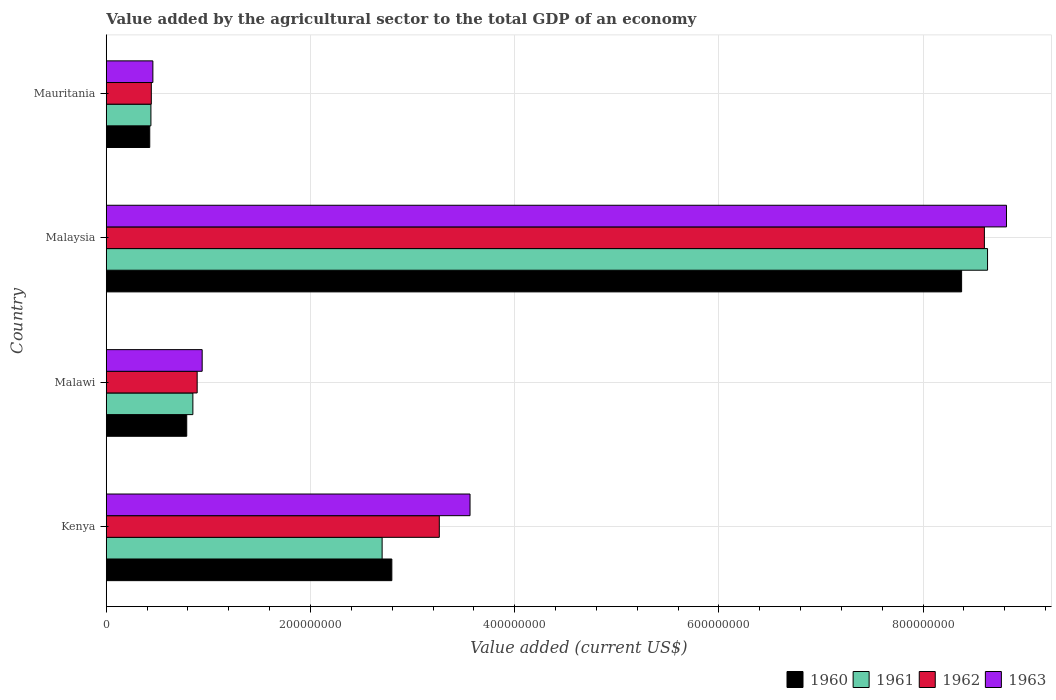Are the number of bars per tick equal to the number of legend labels?
Give a very brief answer. Yes. Are the number of bars on each tick of the Y-axis equal?
Keep it short and to the point. Yes. What is the label of the 4th group of bars from the top?
Your response must be concise. Kenya. In how many cases, is the number of bars for a given country not equal to the number of legend labels?
Provide a short and direct response. 0. What is the value added by the agricultural sector to the total GDP in 1961 in Malaysia?
Your response must be concise. 8.63e+08. Across all countries, what is the maximum value added by the agricultural sector to the total GDP in 1961?
Offer a very short reply. 8.63e+08. Across all countries, what is the minimum value added by the agricultural sector to the total GDP in 1963?
Offer a very short reply. 4.57e+07. In which country was the value added by the agricultural sector to the total GDP in 1962 maximum?
Provide a short and direct response. Malaysia. In which country was the value added by the agricultural sector to the total GDP in 1963 minimum?
Offer a terse response. Mauritania. What is the total value added by the agricultural sector to the total GDP in 1961 in the graph?
Provide a short and direct response. 1.26e+09. What is the difference between the value added by the agricultural sector to the total GDP in 1961 in Malaysia and that in Mauritania?
Keep it short and to the point. 8.19e+08. What is the difference between the value added by the agricultural sector to the total GDP in 1963 in Kenya and the value added by the agricultural sector to the total GDP in 1961 in Mauritania?
Make the answer very short. 3.13e+08. What is the average value added by the agricultural sector to the total GDP in 1963 per country?
Provide a succinct answer. 3.44e+08. What is the difference between the value added by the agricultural sector to the total GDP in 1960 and value added by the agricultural sector to the total GDP in 1962 in Kenya?
Give a very brief answer. -4.65e+07. What is the ratio of the value added by the agricultural sector to the total GDP in 1963 in Kenya to that in Mauritania?
Keep it short and to the point. 7.8. What is the difference between the highest and the second highest value added by the agricultural sector to the total GDP in 1961?
Offer a terse response. 5.93e+08. What is the difference between the highest and the lowest value added by the agricultural sector to the total GDP in 1961?
Your answer should be very brief. 8.19e+08. Is the sum of the value added by the agricultural sector to the total GDP in 1961 in Malaysia and Mauritania greater than the maximum value added by the agricultural sector to the total GDP in 1960 across all countries?
Offer a very short reply. Yes. Is it the case that in every country, the sum of the value added by the agricultural sector to the total GDP in 1962 and value added by the agricultural sector to the total GDP in 1961 is greater than the sum of value added by the agricultural sector to the total GDP in 1963 and value added by the agricultural sector to the total GDP in 1960?
Make the answer very short. No. What does the 4th bar from the top in Mauritania represents?
Offer a very short reply. 1960. What does the 3rd bar from the bottom in Mauritania represents?
Give a very brief answer. 1962. How many bars are there?
Make the answer very short. 16. Are the values on the major ticks of X-axis written in scientific E-notation?
Offer a terse response. No. Does the graph contain any zero values?
Make the answer very short. No. Does the graph contain grids?
Offer a very short reply. Yes. Where does the legend appear in the graph?
Your response must be concise. Bottom right. How are the legend labels stacked?
Your answer should be compact. Horizontal. What is the title of the graph?
Your answer should be compact. Value added by the agricultural sector to the total GDP of an economy. Does "2010" appear as one of the legend labels in the graph?
Offer a very short reply. No. What is the label or title of the X-axis?
Your response must be concise. Value added (current US$). What is the label or title of the Y-axis?
Provide a short and direct response. Country. What is the Value added (current US$) in 1960 in Kenya?
Your answer should be compact. 2.80e+08. What is the Value added (current US$) of 1961 in Kenya?
Provide a succinct answer. 2.70e+08. What is the Value added (current US$) in 1962 in Kenya?
Provide a short and direct response. 3.26e+08. What is the Value added (current US$) of 1963 in Kenya?
Your response must be concise. 3.56e+08. What is the Value added (current US$) in 1960 in Malawi?
Your answer should be compact. 7.88e+07. What is the Value added (current US$) of 1961 in Malawi?
Ensure brevity in your answer.  8.48e+07. What is the Value added (current US$) in 1962 in Malawi?
Your response must be concise. 8.90e+07. What is the Value added (current US$) of 1963 in Malawi?
Give a very brief answer. 9.39e+07. What is the Value added (current US$) in 1960 in Malaysia?
Offer a terse response. 8.38e+08. What is the Value added (current US$) in 1961 in Malaysia?
Provide a succinct answer. 8.63e+08. What is the Value added (current US$) of 1962 in Malaysia?
Your answer should be very brief. 8.60e+08. What is the Value added (current US$) in 1963 in Malaysia?
Your answer should be compact. 8.82e+08. What is the Value added (current US$) of 1960 in Mauritania?
Offer a very short reply. 4.26e+07. What is the Value added (current US$) of 1961 in Mauritania?
Your answer should be very brief. 4.37e+07. What is the Value added (current US$) of 1962 in Mauritania?
Offer a very short reply. 4.41e+07. What is the Value added (current US$) of 1963 in Mauritania?
Give a very brief answer. 4.57e+07. Across all countries, what is the maximum Value added (current US$) in 1960?
Offer a terse response. 8.38e+08. Across all countries, what is the maximum Value added (current US$) in 1961?
Your response must be concise. 8.63e+08. Across all countries, what is the maximum Value added (current US$) of 1962?
Your response must be concise. 8.60e+08. Across all countries, what is the maximum Value added (current US$) of 1963?
Your answer should be compact. 8.82e+08. Across all countries, what is the minimum Value added (current US$) of 1960?
Provide a succinct answer. 4.26e+07. Across all countries, what is the minimum Value added (current US$) of 1961?
Offer a very short reply. 4.37e+07. Across all countries, what is the minimum Value added (current US$) in 1962?
Keep it short and to the point. 4.41e+07. Across all countries, what is the minimum Value added (current US$) in 1963?
Your response must be concise. 4.57e+07. What is the total Value added (current US$) in 1960 in the graph?
Your response must be concise. 1.24e+09. What is the total Value added (current US$) of 1961 in the graph?
Give a very brief answer. 1.26e+09. What is the total Value added (current US$) of 1962 in the graph?
Your answer should be very brief. 1.32e+09. What is the total Value added (current US$) of 1963 in the graph?
Keep it short and to the point. 1.38e+09. What is the difference between the Value added (current US$) in 1960 in Kenya and that in Malawi?
Give a very brief answer. 2.01e+08. What is the difference between the Value added (current US$) in 1961 in Kenya and that in Malawi?
Provide a short and direct response. 1.85e+08. What is the difference between the Value added (current US$) of 1962 in Kenya and that in Malawi?
Offer a very short reply. 2.37e+08. What is the difference between the Value added (current US$) of 1963 in Kenya and that in Malawi?
Provide a succinct answer. 2.62e+08. What is the difference between the Value added (current US$) of 1960 in Kenya and that in Malaysia?
Your answer should be very brief. -5.58e+08. What is the difference between the Value added (current US$) of 1961 in Kenya and that in Malaysia?
Ensure brevity in your answer.  -5.93e+08. What is the difference between the Value added (current US$) in 1962 in Kenya and that in Malaysia?
Make the answer very short. -5.34e+08. What is the difference between the Value added (current US$) of 1963 in Kenya and that in Malaysia?
Offer a terse response. -5.25e+08. What is the difference between the Value added (current US$) in 1960 in Kenya and that in Mauritania?
Make the answer very short. 2.37e+08. What is the difference between the Value added (current US$) in 1961 in Kenya and that in Mauritania?
Provide a short and direct response. 2.26e+08. What is the difference between the Value added (current US$) of 1962 in Kenya and that in Mauritania?
Make the answer very short. 2.82e+08. What is the difference between the Value added (current US$) of 1963 in Kenya and that in Mauritania?
Ensure brevity in your answer.  3.11e+08. What is the difference between the Value added (current US$) of 1960 in Malawi and that in Malaysia?
Give a very brief answer. -7.59e+08. What is the difference between the Value added (current US$) of 1961 in Malawi and that in Malaysia?
Your response must be concise. -7.78e+08. What is the difference between the Value added (current US$) in 1962 in Malawi and that in Malaysia?
Keep it short and to the point. -7.71e+08. What is the difference between the Value added (current US$) of 1963 in Malawi and that in Malaysia?
Offer a very short reply. -7.88e+08. What is the difference between the Value added (current US$) in 1960 in Malawi and that in Mauritania?
Provide a short and direct response. 3.62e+07. What is the difference between the Value added (current US$) in 1961 in Malawi and that in Mauritania?
Provide a succinct answer. 4.11e+07. What is the difference between the Value added (current US$) of 1962 in Malawi and that in Mauritania?
Provide a short and direct response. 4.49e+07. What is the difference between the Value added (current US$) of 1963 in Malawi and that in Mauritania?
Provide a short and direct response. 4.83e+07. What is the difference between the Value added (current US$) of 1960 in Malaysia and that in Mauritania?
Keep it short and to the point. 7.95e+08. What is the difference between the Value added (current US$) of 1961 in Malaysia and that in Mauritania?
Your answer should be compact. 8.19e+08. What is the difference between the Value added (current US$) in 1962 in Malaysia and that in Mauritania?
Provide a succinct answer. 8.16e+08. What is the difference between the Value added (current US$) in 1963 in Malaysia and that in Mauritania?
Keep it short and to the point. 8.36e+08. What is the difference between the Value added (current US$) of 1960 in Kenya and the Value added (current US$) of 1961 in Malawi?
Your answer should be very brief. 1.95e+08. What is the difference between the Value added (current US$) of 1960 in Kenya and the Value added (current US$) of 1962 in Malawi?
Provide a succinct answer. 1.91e+08. What is the difference between the Value added (current US$) of 1960 in Kenya and the Value added (current US$) of 1963 in Malawi?
Ensure brevity in your answer.  1.86e+08. What is the difference between the Value added (current US$) of 1961 in Kenya and the Value added (current US$) of 1962 in Malawi?
Give a very brief answer. 1.81e+08. What is the difference between the Value added (current US$) in 1961 in Kenya and the Value added (current US$) in 1963 in Malawi?
Provide a succinct answer. 1.76e+08. What is the difference between the Value added (current US$) in 1962 in Kenya and the Value added (current US$) in 1963 in Malawi?
Provide a short and direct response. 2.32e+08. What is the difference between the Value added (current US$) of 1960 in Kenya and the Value added (current US$) of 1961 in Malaysia?
Your response must be concise. -5.83e+08. What is the difference between the Value added (current US$) of 1960 in Kenya and the Value added (current US$) of 1962 in Malaysia?
Make the answer very short. -5.80e+08. What is the difference between the Value added (current US$) in 1960 in Kenya and the Value added (current US$) in 1963 in Malaysia?
Your answer should be very brief. -6.02e+08. What is the difference between the Value added (current US$) of 1961 in Kenya and the Value added (current US$) of 1962 in Malaysia?
Give a very brief answer. -5.90e+08. What is the difference between the Value added (current US$) of 1961 in Kenya and the Value added (current US$) of 1963 in Malaysia?
Your response must be concise. -6.11e+08. What is the difference between the Value added (current US$) of 1962 in Kenya and the Value added (current US$) of 1963 in Malaysia?
Offer a terse response. -5.55e+08. What is the difference between the Value added (current US$) of 1960 in Kenya and the Value added (current US$) of 1961 in Mauritania?
Offer a terse response. 2.36e+08. What is the difference between the Value added (current US$) of 1960 in Kenya and the Value added (current US$) of 1962 in Mauritania?
Your answer should be very brief. 2.36e+08. What is the difference between the Value added (current US$) in 1960 in Kenya and the Value added (current US$) in 1963 in Mauritania?
Keep it short and to the point. 2.34e+08. What is the difference between the Value added (current US$) of 1961 in Kenya and the Value added (current US$) of 1962 in Mauritania?
Give a very brief answer. 2.26e+08. What is the difference between the Value added (current US$) in 1961 in Kenya and the Value added (current US$) in 1963 in Mauritania?
Ensure brevity in your answer.  2.25e+08. What is the difference between the Value added (current US$) in 1962 in Kenya and the Value added (current US$) in 1963 in Mauritania?
Your answer should be compact. 2.81e+08. What is the difference between the Value added (current US$) in 1960 in Malawi and the Value added (current US$) in 1961 in Malaysia?
Your answer should be compact. -7.84e+08. What is the difference between the Value added (current US$) of 1960 in Malawi and the Value added (current US$) of 1962 in Malaysia?
Make the answer very short. -7.81e+08. What is the difference between the Value added (current US$) of 1960 in Malawi and the Value added (current US$) of 1963 in Malaysia?
Your response must be concise. -8.03e+08. What is the difference between the Value added (current US$) of 1961 in Malawi and the Value added (current US$) of 1962 in Malaysia?
Provide a short and direct response. -7.75e+08. What is the difference between the Value added (current US$) of 1961 in Malawi and the Value added (current US$) of 1963 in Malaysia?
Offer a very short reply. -7.97e+08. What is the difference between the Value added (current US$) in 1962 in Malawi and the Value added (current US$) in 1963 in Malaysia?
Give a very brief answer. -7.93e+08. What is the difference between the Value added (current US$) of 1960 in Malawi and the Value added (current US$) of 1961 in Mauritania?
Provide a succinct answer. 3.51e+07. What is the difference between the Value added (current US$) in 1960 in Malawi and the Value added (current US$) in 1962 in Mauritania?
Your answer should be compact. 3.47e+07. What is the difference between the Value added (current US$) of 1960 in Malawi and the Value added (current US$) of 1963 in Mauritania?
Provide a short and direct response. 3.32e+07. What is the difference between the Value added (current US$) of 1961 in Malawi and the Value added (current US$) of 1962 in Mauritania?
Ensure brevity in your answer.  4.07e+07. What is the difference between the Value added (current US$) in 1961 in Malawi and the Value added (current US$) in 1963 in Mauritania?
Ensure brevity in your answer.  3.92e+07. What is the difference between the Value added (current US$) of 1962 in Malawi and the Value added (current US$) of 1963 in Mauritania?
Provide a succinct answer. 4.34e+07. What is the difference between the Value added (current US$) in 1960 in Malaysia and the Value added (current US$) in 1961 in Mauritania?
Your answer should be compact. 7.94e+08. What is the difference between the Value added (current US$) of 1960 in Malaysia and the Value added (current US$) of 1962 in Mauritania?
Offer a terse response. 7.94e+08. What is the difference between the Value added (current US$) in 1960 in Malaysia and the Value added (current US$) in 1963 in Mauritania?
Offer a very short reply. 7.92e+08. What is the difference between the Value added (current US$) of 1961 in Malaysia and the Value added (current US$) of 1962 in Mauritania?
Keep it short and to the point. 8.19e+08. What is the difference between the Value added (current US$) of 1961 in Malaysia and the Value added (current US$) of 1963 in Mauritania?
Keep it short and to the point. 8.17e+08. What is the difference between the Value added (current US$) in 1962 in Malaysia and the Value added (current US$) in 1963 in Mauritania?
Your response must be concise. 8.14e+08. What is the average Value added (current US$) of 1960 per country?
Make the answer very short. 3.10e+08. What is the average Value added (current US$) of 1961 per country?
Your response must be concise. 3.15e+08. What is the average Value added (current US$) of 1962 per country?
Offer a terse response. 3.30e+08. What is the average Value added (current US$) of 1963 per country?
Offer a very short reply. 3.44e+08. What is the difference between the Value added (current US$) of 1960 and Value added (current US$) of 1961 in Kenya?
Ensure brevity in your answer.  9.51e+06. What is the difference between the Value added (current US$) in 1960 and Value added (current US$) in 1962 in Kenya?
Your response must be concise. -4.65e+07. What is the difference between the Value added (current US$) of 1960 and Value added (current US$) of 1963 in Kenya?
Offer a terse response. -7.66e+07. What is the difference between the Value added (current US$) of 1961 and Value added (current US$) of 1962 in Kenya?
Offer a very short reply. -5.60e+07. What is the difference between the Value added (current US$) of 1961 and Value added (current US$) of 1963 in Kenya?
Your answer should be very brief. -8.61e+07. What is the difference between the Value added (current US$) in 1962 and Value added (current US$) in 1963 in Kenya?
Provide a succinct answer. -3.01e+07. What is the difference between the Value added (current US$) of 1960 and Value added (current US$) of 1961 in Malawi?
Your answer should be very brief. -6.02e+06. What is the difference between the Value added (current US$) in 1960 and Value added (current US$) in 1962 in Malawi?
Give a very brief answer. -1.02e+07. What is the difference between the Value added (current US$) of 1960 and Value added (current US$) of 1963 in Malawi?
Provide a short and direct response. -1.51e+07. What is the difference between the Value added (current US$) of 1961 and Value added (current US$) of 1962 in Malawi?
Your answer should be very brief. -4.20e+06. What is the difference between the Value added (current US$) of 1961 and Value added (current US$) of 1963 in Malawi?
Provide a succinct answer. -9.10e+06. What is the difference between the Value added (current US$) of 1962 and Value added (current US$) of 1963 in Malawi?
Your answer should be compact. -4.90e+06. What is the difference between the Value added (current US$) of 1960 and Value added (current US$) of 1961 in Malaysia?
Give a very brief answer. -2.54e+07. What is the difference between the Value added (current US$) in 1960 and Value added (current US$) in 1962 in Malaysia?
Your answer should be very brief. -2.23e+07. What is the difference between the Value added (current US$) in 1960 and Value added (current US$) in 1963 in Malaysia?
Your response must be concise. -4.39e+07. What is the difference between the Value added (current US$) in 1961 and Value added (current US$) in 1962 in Malaysia?
Ensure brevity in your answer.  3.09e+06. What is the difference between the Value added (current US$) in 1961 and Value added (current US$) in 1963 in Malaysia?
Provide a succinct answer. -1.85e+07. What is the difference between the Value added (current US$) of 1962 and Value added (current US$) of 1963 in Malaysia?
Make the answer very short. -2.16e+07. What is the difference between the Value added (current US$) of 1960 and Value added (current US$) of 1961 in Mauritania?
Your response must be concise. -1.15e+06. What is the difference between the Value added (current US$) of 1960 and Value added (current US$) of 1962 in Mauritania?
Give a very brief answer. -1.54e+06. What is the difference between the Value added (current US$) in 1960 and Value added (current US$) in 1963 in Mauritania?
Provide a short and direct response. -3.07e+06. What is the difference between the Value added (current US$) of 1961 and Value added (current US$) of 1962 in Mauritania?
Your response must be concise. -3.84e+05. What is the difference between the Value added (current US$) in 1961 and Value added (current US$) in 1963 in Mauritania?
Make the answer very short. -1.92e+06. What is the difference between the Value added (current US$) in 1962 and Value added (current US$) in 1963 in Mauritania?
Your answer should be very brief. -1.54e+06. What is the ratio of the Value added (current US$) of 1960 in Kenya to that in Malawi?
Your response must be concise. 3.55. What is the ratio of the Value added (current US$) in 1961 in Kenya to that in Malawi?
Give a very brief answer. 3.18. What is the ratio of the Value added (current US$) of 1962 in Kenya to that in Malawi?
Offer a terse response. 3.66. What is the ratio of the Value added (current US$) in 1963 in Kenya to that in Malawi?
Your answer should be very brief. 3.79. What is the ratio of the Value added (current US$) in 1960 in Kenya to that in Malaysia?
Offer a terse response. 0.33. What is the ratio of the Value added (current US$) of 1961 in Kenya to that in Malaysia?
Your answer should be very brief. 0.31. What is the ratio of the Value added (current US$) in 1962 in Kenya to that in Malaysia?
Your response must be concise. 0.38. What is the ratio of the Value added (current US$) in 1963 in Kenya to that in Malaysia?
Ensure brevity in your answer.  0.4. What is the ratio of the Value added (current US$) of 1960 in Kenya to that in Mauritania?
Your answer should be compact. 6.57. What is the ratio of the Value added (current US$) of 1961 in Kenya to that in Mauritania?
Your answer should be very brief. 6.18. What is the ratio of the Value added (current US$) of 1962 in Kenya to that in Mauritania?
Offer a terse response. 7.39. What is the ratio of the Value added (current US$) of 1963 in Kenya to that in Mauritania?
Give a very brief answer. 7.8. What is the ratio of the Value added (current US$) in 1960 in Malawi to that in Malaysia?
Provide a succinct answer. 0.09. What is the ratio of the Value added (current US$) of 1961 in Malawi to that in Malaysia?
Make the answer very short. 0.1. What is the ratio of the Value added (current US$) in 1962 in Malawi to that in Malaysia?
Make the answer very short. 0.1. What is the ratio of the Value added (current US$) in 1963 in Malawi to that in Malaysia?
Make the answer very short. 0.11. What is the ratio of the Value added (current US$) of 1960 in Malawi to that in Mauritania?
Keep it short and to the point. 1.85. What is the ratio of the Value added (current US$) in 1961 in Malawi to that in Mauritania?
Give a very brief answer. 1.94. What is the ratio of the Value added (current US$) in 1962 in Malawi to that in Mauritania?
Offer a very short reply. 2.02. What is the ratio of the Value added (current US$) in 1963 in Malawi to that in Mauritania?
Your answer should be compact. 2.06. What is the ratio of the Value added (current US$) of 1960 in Malaysia to that in Mauritania?
Provide a short and direct response. 19.67. What is the ratio of the Value added (current US$) in 1961 in Malaysia to that in Mauritania?
Give a very brief answer. 19.73. What is the ratio of the Value added (current US$) of 1962 in Malaysia to that in Mauritania?
Your response must be concise. 19.49. What is the ratio of the Value added (current US$) in 1963 in Malaysia to that in Mauritania?
Ensure brevity in your answer.  19.31. What is the difference between the highest and the second highest Value added (current US$) of 1960?
Make the answer very short. 5.58e+08. What is the difference between the highest and the second highest Value added (current US$) of 1961?
Give a very brief answer. 5.93e+08. What is the difference between the highest and the second highest Value added (current US$) in 1962?
Make the answer very short. 5.34e+08. What is the difference between the highest and the second highest Value added (current US$) of 1963?
Keep it short and to the point. 5.25e+08. What is the difference between the highest and the lowest Value added (current US$) in 1960?
Offer a very short reply. 7.95e+08. What is the difference between the highest and the lowest Value added (current US$) of 1961?
Your answer should be compact. 8.19e+08. What is the difference between the highest and the lowest Value added (current US$) of 1962?
Offer a very short reply. 8.16e+08. What is the difference between the highest and the lowest Value added (current US$) in 1963?
Keep it short and to the point. 8.36e+08. 